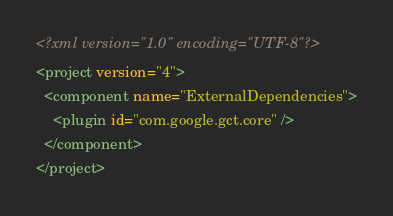<code> <loc_0><loc_0><loc_500><loc_500><_XML_><?xml version="1.0" encoding="UTF-8"?>
<project version="4">
  <component name="ExternalDependencies">
    <plugin id="com.google.gct.core" />
  </component>
</project>

</code> 